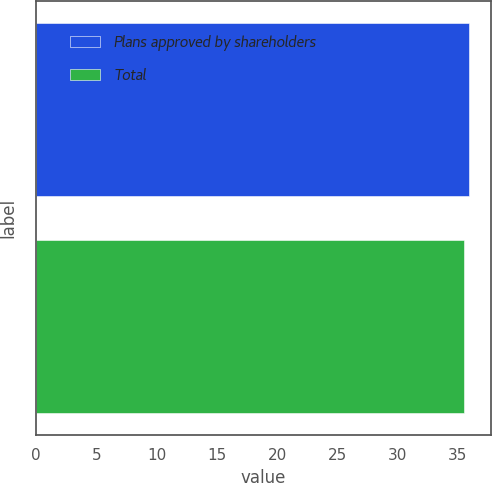Convert chart. <chart><loc_0><loc_0><loc_500><loc_500><bar_chart><fcel>Plans approved by shareholders<fcel>Total<nl><fcel>35.91<fcel>35.47<nl></chart> 